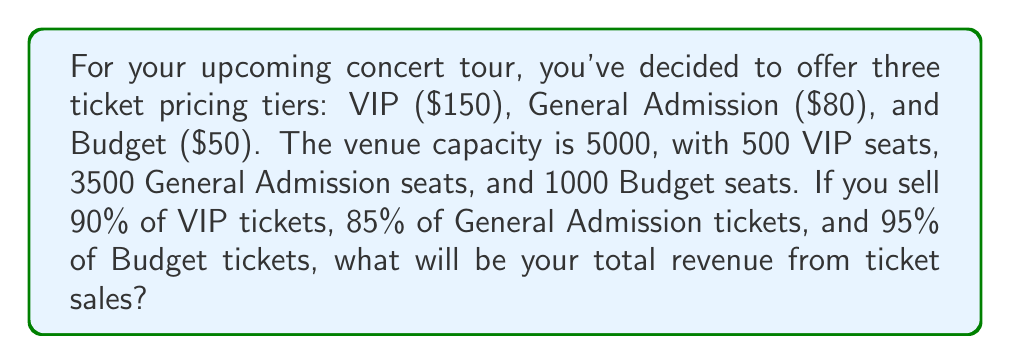Can you solve this math problem? Let's break this down step-by-step:

1. Calculate the number of tickets sold for each tier:
   VIP: $500 \times 0.90 = 450$ tickets
   General Admission: $3500 \times 0.85 = 2975$ tickets
   Budget: $1000 \times 0.95 = 950$ tickets

2. Calculate the revenue for each tier:
   VIP: $450 \times \$150 = \$67,500$
   General Admission: $2975 \times \$80 = \$238,000$
   Budget: $950 \times \$50 = \$47,500$

3. Sum up the total revenue:
   $$\text{Total Revenue} = \$67,500 + \$238,000 + \$47,500 = \$353,000$$
Answer: $353,000 